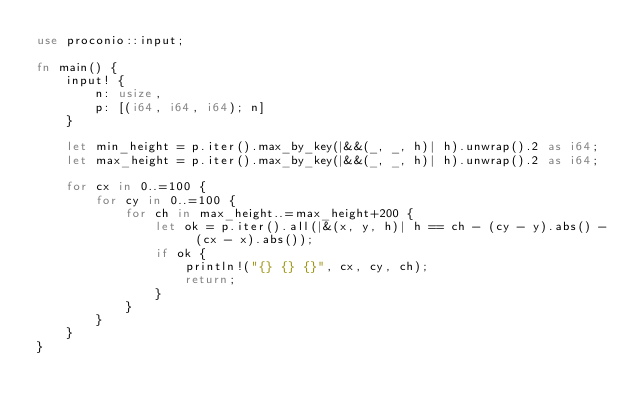Convert code to text. <code><loc_0><loc_0><loc_500><loc_500><_Rust_>use proconio::input;

fn main() {
    input! {
        n: usize,
        p: [(i64, i64, i64); n]
    }

    let min_height = p.iter().max_by_key(|&&(_, _, h)| h).unwrap().2 as i64;
    let max_height = p.iter().max_by_key(|&&(_, _, h)| h).unwrap().2 as i64;

    for cx in 0..=100 {
        for cy in 0..=100 {
            for ch in max_height..=max_height+200 {
                let ok = p.iter().all(|&(x, y, h)| h == ch - (cy - y).abs() - (cx - x).abs());
                if ok {
                    println!("{} {} {}", cx, cy, ch);
                    return;
                }
            }
        }
    }
}</code> 